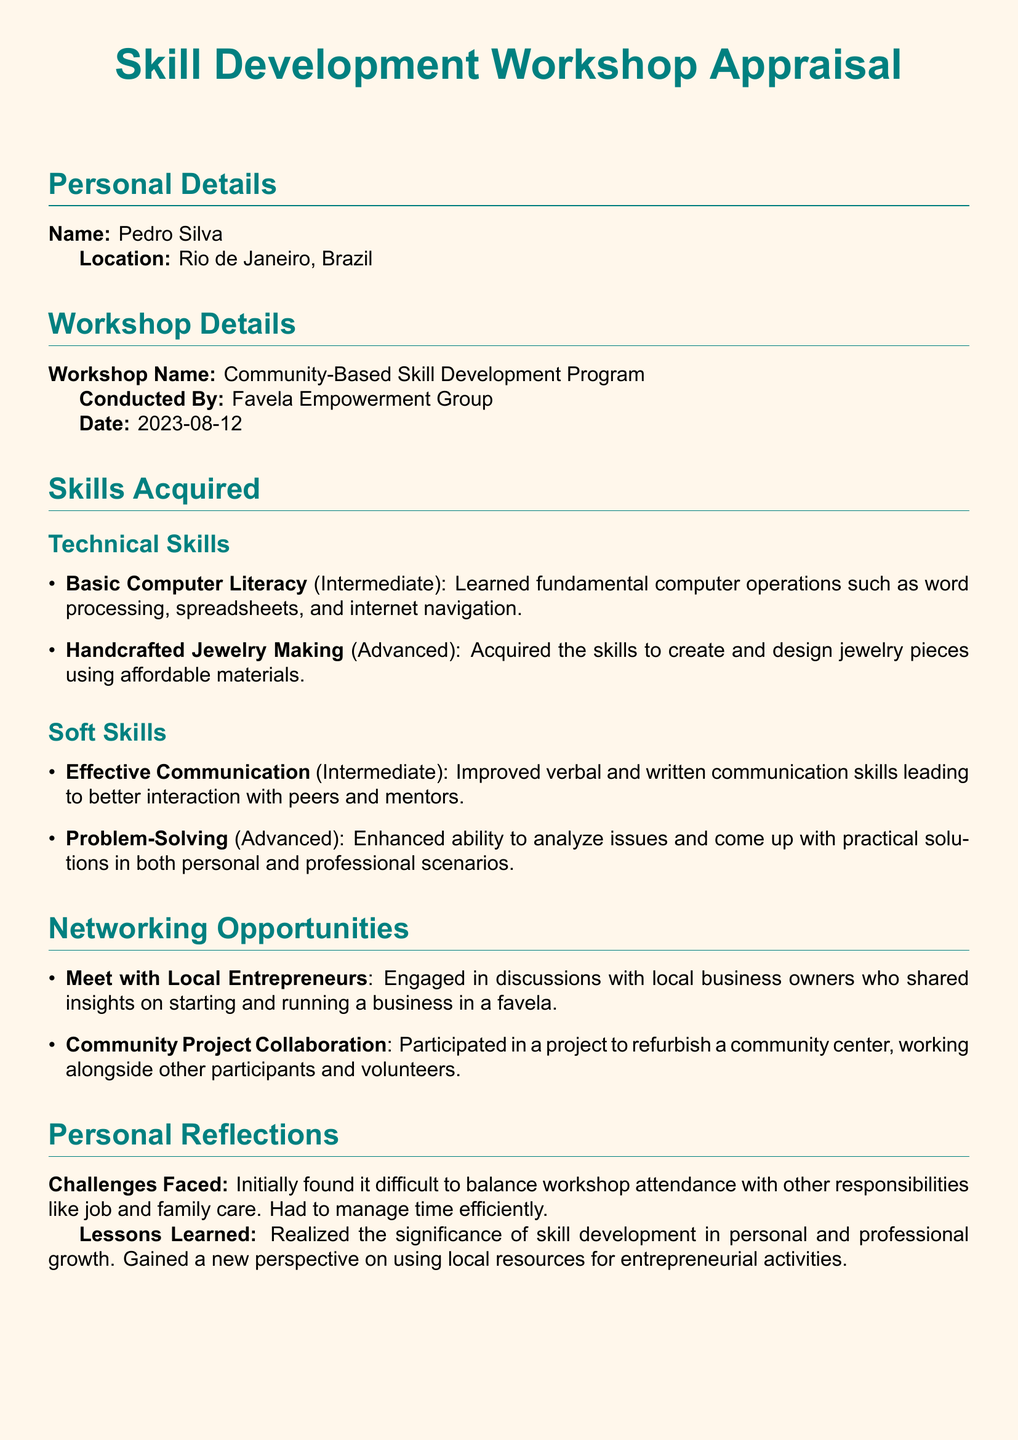What is the name of the participant? The participant's name is provided in the Personal Details section as Pedro Silva.
Answer: Pedro Silva What was the date of the workshop? The date of the workshop is listed in the Workshop Details section.
Answer: 2023-08-12 Who conducted the workshop? The organization that conducted the workshop is mentioned in the Workshop Details section.
Answer: Favela Empowerment Group What advanced technical skill was acquired? The advanced technical skill is specified under the Skills Acquired section in Technical Skills.
Answer: Handcrafted Jewelry Making What challenge did the participant face? The challenge faced is documented under Personal Reflections regarding balancing responsibilities.
Answer: Time management What is the short-term goal of the participant? The short-term goal is stated under Future Goals following a brief description of the goal.
Answer: Handcrafted jewelry business What type of skill is Effective Communication categorized as? The categorization of Effective Communication is noted in the Skills Acquired section under Soft Skills.
Answer: Intermediate What collaborative project did the participant engage in? The project is mentioned in the Networking Opportunities section, detailing community involvement.
Answer: Refurbish a community center What lesson did the participant learn regarding skill development? The lesson learned is expressed in the Personal Reflections section related to personal growth.
Answer: Significance of skill development 